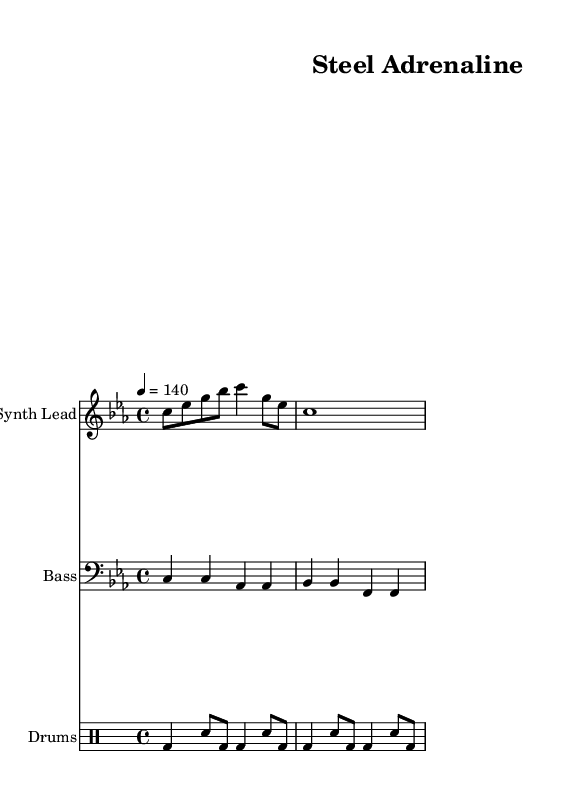What is the key signature of this music? The key signature is C minor, which has three flats indicated by the key signature on the staff before the first note.
Answer: C minor What is the time signature of this piece? The time signature is 4/4, shown at the beginning of the score on the staff, specifying that there are four beats per measure and the quarter note gets one beat.
Answer: 4/4 What is the tempo marking for this piece? The tempo marking indicates that the piece should be played at a speed of 140 beats per minute, which is noted under the tempo indication.
Answer: 140 How many staves are included in this score? There are three staves presented in the score: one for Synth Lead, one for Bass, and one for Drums, which are clearly labeled at the beginning of each staff.
Answer: 3 What type of drum pattern is used in this piece? The drum pattern features bass drum and snare drum sounds, which are denoted using the respective symbols in the specified drum staff.
Answer: Bass and snare How many beats are there in one measure of the drum pattern? Each measure of the drum pattern contains four beats, consistent with the 4/4 time signature applied throughout the piece.
Answer: 4 What is the structure of the synth lead in the first measure? The synth lead in the first measure consists of a series of eighth and quarter notes, creating a rhythm that supports the overall upbeat feel of the track.
Answer: Eighth and quarter notes 